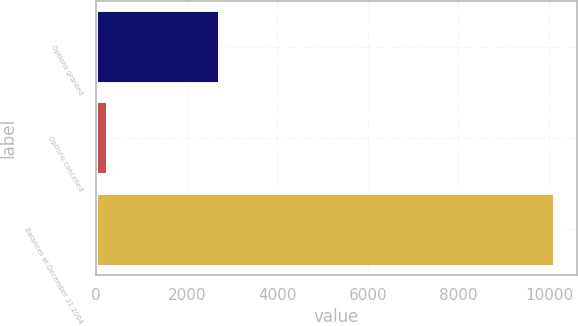Convert chart. <chart><loc_0><loc_0><loc_500><loc_500><bar_chart><fcel>Options granted<fcel>Options cancelled<fcel>Balances at December 31 2004<nl><fcel>2720<fcel>244<fcel>10112<nl></chart> 